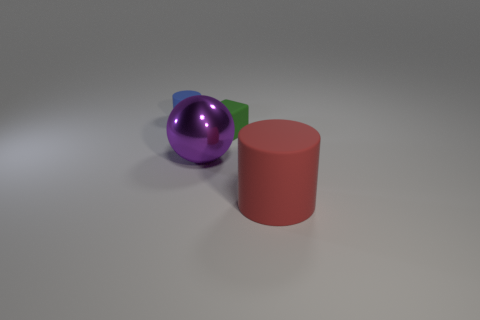Are there any small spheres that have the same color as the big sphere?
Provide a succinct answer. No. What number of other objects are there of the same shape as the tiny green thing?
Provide a succinct answer. 0. There is a small matte thing that is right of the big ball; what is its shape?
Ensure brevity in your answer.  Cube. There is a large matte object; does it have the same shape as the matte object to the left of the big purple metal sphere?
Provide a short and direct response. Yes. What is the size of the thing that is on the right side of the purple ball and left of the red rubber cylinder?
Offer a very short reply. Small. There is a thing that is both in front of the tiny block and to the right of the purple sphere; what color is it?
Keep it short and to the point. Red. Is there any other thing that has the same material as the purple object?
Your answer should be very brief. No. Is the number of green objects in front of the big red matte thing less than the number of big spheres that are left of the tiny cylinder?
Give a very brief answer. No. Is there any other thing that is the same color as the small matte cube?
Offer a very short reply. No. The green rubber thing has what shape?
Your answer should be very brief. Cube. 